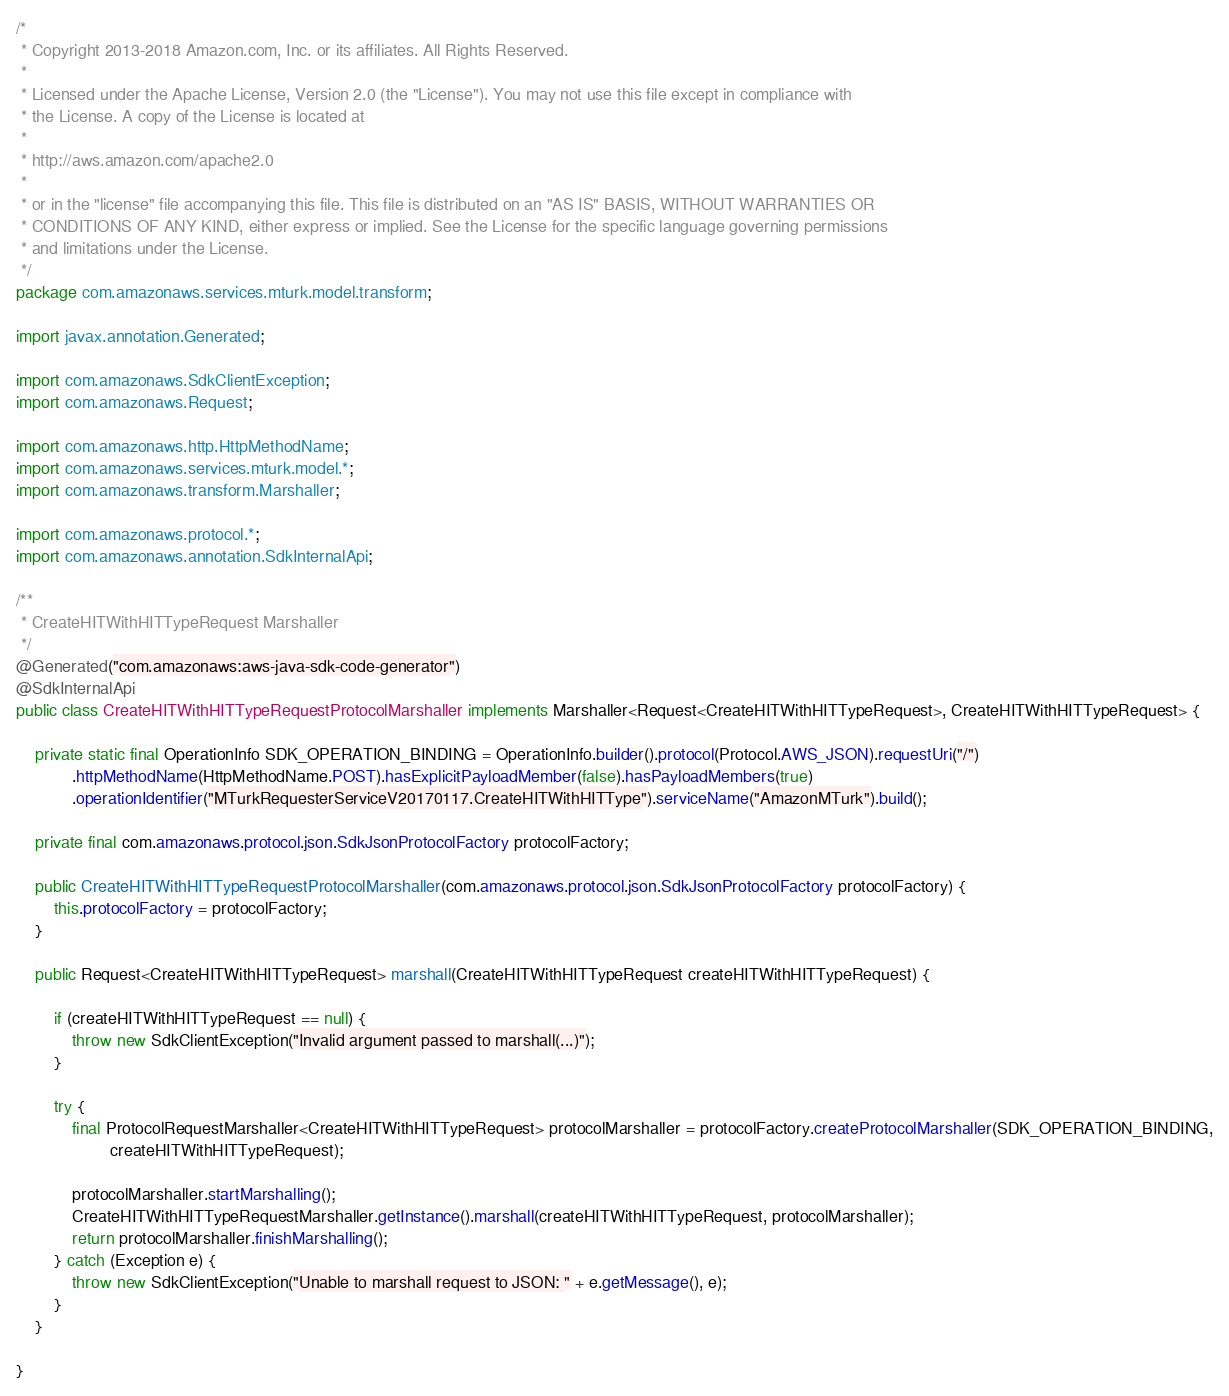<code> <loc_0><loc_0><loc_500><loc_500><_Java_>/*
 * Copyright 2013-2018 Amazon.com, Inc. or its affiliates. All Rights Reserved.
 * 
 * Licensed under the Apache License, Version 2.0 (the "License"). You may not use this file except in compliance with
 * the License. A copy of the License is located at
 * 
 * http://aws.amazon.com/apache2.0
 * 
 * or in the "license" file accompanying this file. This file is distributed on an "AS IS" BASIS, WITHOUT WARRANTIES OR
 * CONDITIONS OF ANY KIND, either express or implied. See the License for the specific language governing permissions
 * and limitations under the License.
 */
package com.amazonaws.services.mturk.model.transform;

import javax.annotation.Generated;

import com.amazonaws.SdkClientException;
import com.amazonaws.Request;

import com.amazonaws.http.HttpMethodName;
import com.amazonaws.services.mturk.model.*;
import com.amazonaws.transform.Marshaller;

import com.amazonaws.protocol.*;
import com.amazonaws.annotation.SdkInternalApi;

/**
 * CreateHITWithHITTypeRequest Marshaller
 */
@Generated("com.amazonaws:aws-java-sdk-code-generator")
@SdkInternalApi
public class CreateHITWithHITTypeRequestProtocolMarshaller implements Marshaller<Request<CreateHITWithHITTypeRequest>, CreateHITWithHITTypeRequest> {

    private static final OperationInfo SDK_OPERATION_BINDING = OperationInfo.builder().protocol(Protocol.AWS_JSON).requestUri("/")
            .httpMethodName(HttpMethodName.POST).hasExplicitPayloadMember(false).hasPayloadMembers(true)
            .operationIdentifier("MTurkRequesterServiceV20170117.CreateHITWithHITType").serviceName("AmazonMTurk").build();

    private final com.amazonaws.protocol.json.SdkJsonProtocolFactory protocolFactory;

    public CreateHITWithHITTypeRequestProtocolMarshaller(com.amazonaws.protocol.json.SdkJsonProtocolFactory protocolFactory) {
        this.protocolFactory = protocolFactory;
    }

    public Request<CreateHITWithHITTypeRequest> marshall(CreateHITWithHITTypeRequest createHITWithHITTypeRequest) {

        if (createHITWithHITTypeRequest == null) {
            throw new SdkClientException("Invalid argument passed to marshall(...)");
        }

        try {
            final ProtocolRequestMarshaller<CreateHITWithHITTypeRequest> protocolMarshaller = protocolFactory.createProtocolMarshaller(SDK_OPERATION_BINDING,
                    createHITWithHITTypeRequest);

            protocolMarshaller.startMarshalling();
            CreateHITWithHITTypeRequestMarshaller.getInstance().marshall(createHITWithHITTypeRequest, protocolMarshaller);
            return protocolMarshaller.finishMarshalling();
        } catch (Exception e) {
            throw new SdkClientException("Unable to marshall request to JSON: " + e.getMessage(), e);
        }
    }

}
</code> 